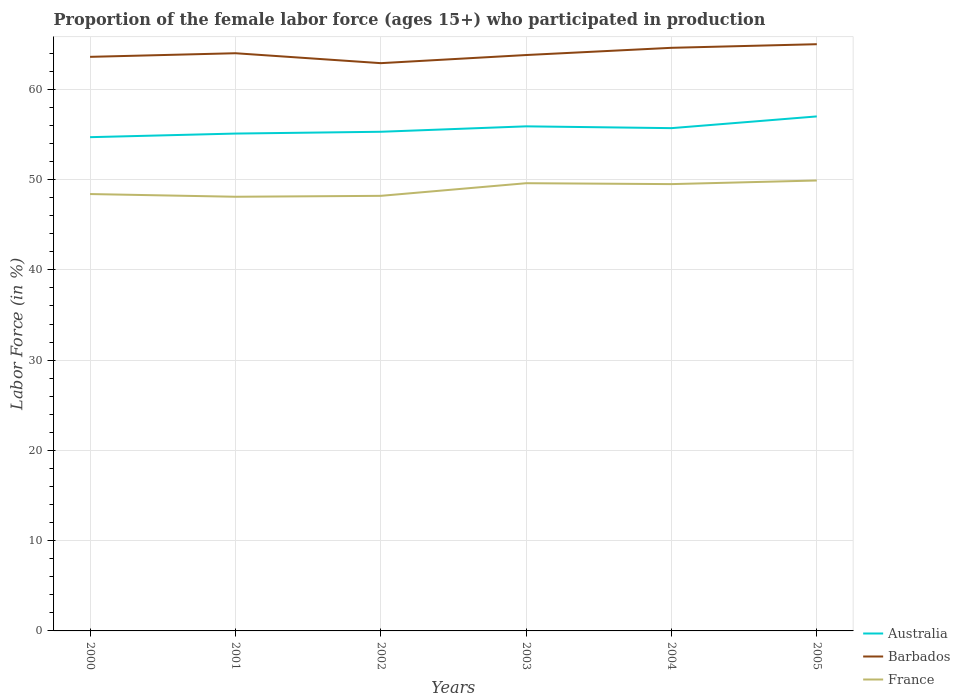How many different coloured lines are there?
Give a very brief answer. 3. Does the line corresponding to Barbados intersect with the line corresponding to France?
Provide a succinct answer. No. Is the number of lines equal to the number of legend labels?
Offer a terse response. Yes. Across all years, what is the maximum proportion of the female labor force who participated in production in France?
Offer a terse response. 48.1. What is the total proportion of the female labor force who participated in production in Australia in the graph?
Your response must be concise. -1.1. What is the difference between the highest and the second highest proportion of the female labor force who participated in production in France?
Offer a terse response. 1.8. What is the difference between the highest and the lowest proportion of the female labor force who participated in production in Barbados?
Offer a very short reply. 3. How many lines are there?
Give a very brief answer. 3. How many years are there in the graph?
Your answer should be very brief. 6. What is the difference between two consecutive major ticks on the Y-axis?
Your answer should be very brief. 10. Are the values on the major ticks of Y-axis written in scientific E-notation?
Offer a terse response. No. Does the graph contain grids?
Your answer should be very brief. Yes. How are the legend labels stacked?
Provide a short and direct response. Vertical. What is the title of the graph?
Give a very brief answer. Proportion of the female labor force (ages 15+) who participated in production. Does "Macedonia" appear as one of the legend labels in the graph?
Your answer should be compact. No. What is the label or title of the X-axis?
Provide a short and direct response. Years. What is the Labor Force (in %) in Australia in 2000?
Make the answer very short. 54.7. What is the Labor Force (in %) in Barbados in 2000?
Ensure brevity in your answer.  63.6. What is the Labor Force (in %) in France in 2000?
Give a very brief answer. 48.4. What is the Labor Force (in %) of Australia in 2001?
Provide a succinct answer. 55.1. What is the Labor Force (in %) of France in 2001?
Provide a short and direct response. 48.1. What is the Labor Force (in %) of Australia in 2002?
Keep it short and to the point. 55.3. What is the Labor Force (in %) of Barbados in 2002?
Your response must be concise. 62.9. What is the Labor Force (in %) in France in 2002?
Your response must be concise. 48.2. What is the Labor Force (in %) of Australia in 2003?
Give a very brief answer. 55.9. What is the Labor Force (in %) in Barbados in 2003?
Ensure brevity in your answer.  63.8. What is the Labor Force (in %) of France in 2003?
Ensure brevity in your answer.  49.6. What is the Labor Force (in %) of Australia in 2004?
Offer a very short reply. 55.7. What is the Labor Force (in %) of Barbados in 2004?
Provide a succinct answer. 64.6. What is the Labor Force (in %) of France in 2004?
Your response must be concise. 49.5. What is the Labor Force (in %) of Australia in 2005?
Your response must be concise. 57. What is the Labor Force (in %) in Barbados in 2005?
Your answer should be very brief. 65. What is the Labor Force (in %) of France in 2005?
Provide a succinct answer. 49.9. Across all years, what is the maximum Labor Force (in %) in France?
Offer a terse response. 49.9. Across all years, what is the minimum Labor Force (in %) of Australia?
Provide a succinct answer. 54.7. Across all years, what is the minimum Labor Force (in %) in Barbados?
Make the answer very short. 62.9. Across all years, what is the minimum Labor Force (in %) in France?
Make the answer very short. 48.1. What is the total Labor Force (in %) of Australia in the graph?
Make the answer very short. 333.7. What is the total Labor Force (in %) of Barbados in the graph?
Offer a terse response. 383.9. What is the total Labor Force (in %) in France in the graph?
Make the answer very short. 293.7. What is the difference between the Labor Force (in %) of France in 2000 and that in 2001?
Give a very brief answer. 0.3. What is the difference between the Labor Force (in %) of France in 2000 and that in 2002?
Your answer should be very brief. 0.2. What is the difference between the Labor Force (in %) of Australia in 2000 and that in 2003?
Your answer should be compact. -1.2. What is the difference between the Labor Force (in %) of Australia in 2000 and that in 2004?
Offer a very short reply. -1. What is the difference between the Labor Force (in %) of Barbados in 2000 and that in 2004?
Ensure brevity in your answer.  -1. What is the difference between the Labor Force (in %) of France in 2000 and that in 2004?
Your answer should be compact. -1.1. What is the difference between the Labor Force (in %) in Australia in 2000 and that in 2005?
Provide a succinct answer. -2.3. What is the difference between the Labor Force (in %) of France in 2001 and that in 2002?
Offer a terse response. -0.1. What is the difference between the Labor Force (in %) of Barbados in 2001 and that in 2003?
Give a very brief answer. 0.2. What is the difference between the Labor Force (in %) in France in 2001 and that in 2003?
Offer a terse response. -1.5. What is the difference between the Labor Force (in %) in Barbados in 2001 and that in 2004?
Your answer should be compact. -0.6. What is the difference between the Labor Force (in %) in France in 2001 and that in 2004?
Your answer should be very brief. -1.4. What is the difference between the Labor Force (in %) in Australia in 2001 and that in 2005?
Make the answer very short. -1.9. What is the difference between the Labor Force (in %) of Barbados in 2001 and that in 2005?
Offer a terse response. -1. What is the difference between the Labor Force (in %) in France in 2001 and that in 2005?
Your response must be concise. -1.8. What is the difference between the Labor Force (in %) in Barbados in 2002 and that in 2003?
Keep it short and to the point. -0.9. What is the difference between the Labor Force (in %) in Australia in 2002 and that in 2004?
Your answer should be very brief. -0.4. What is the difference between the Labor Force (in %) of Barbados in 2002 and that in 2004?
Give a very brief answer. -1.7. What is the difference between the Labor Force (in %) in France in 2002 and that in 2004?
Your answer should be very brief. -1.3. What is the difference between the Labor Force (in %) in Barbados in 2002 and that in 2005?
Offer a very short reply. -2.1. What is the difference between the Labor Force (in %) of Australia in 2003 and that in 2004?
Offer a very short reply. 0.2. What is the difference between the Labor Force (in %) of Barbados in 2003 and that in 2004?
Ensure brevity in your answer.  -0.8. What is the difference between the Labor Force (in %) in France in 2003 and that in 2004?
Give a very brief answer. 0.1. What is the difference between the Labor Force (in %) of France in 2003 and that in 2005?
Offer a very short reply. -0.3. What is the difference between the Labor Force (in %) of Barbados in 2004 and that in 2005?
Offer a terse response. -0.4. What is the difference between the Labor Force (in %) in Australia in 2000 and the Labor Force (in %) in Barbados in 2002?
Your answer should be compact. -8.2. What is the difference between the Labor Force (in %) of Barbados in 2000 and the Labor Force (in %) of France in 2002?
Your response must be concise. 15.4. What is the difference between the Labor Force (in %) in Australia in 2000 and the Labor Force (in %) in France in 2004?
Your response must be concise. 5.2. What is the difference between the Labor Force (in %) in Barbados in 2000 and the Labor Force (in %) in France in 2004?
Provide a succinct answer. 14.1. What is the difference between the Labor Force (in %) in Australia in 2000 and the Labor Force (in %) in Barbados in 2005?
Give a very brief answer. -10.3. What is the difference between the Labor Force (in %) of Australia in 2000 and the Labor Force (in %) of France in 2005?
Provide a succinct answer. 4.8. What is the difference between the Labor Force (in %) in Barbados in 2000 and the Labor Force (in %) in France in 2005?
Your answer should be compact. 13.7. What is the difference between the Labor Force (in %) in Australia in 2001 and the Labor Force (in %) in Barbados in 2002?
Provide a succinct answer. -7.8. What is the difference between the Labor Force (in %) in Australia in 2001 and the Labor Force (in %) in Barbados in 2003?
Keep it short and to the point. -8.7. What is the difference between the Labor Force (in %) of Australia in 2001 and the Labor Force (in %) of France in 2003?
Make the answer very short. 5.5. What is the difference between the Labor Force (in %) of Barbados in 2001 and the Labor Force (in %) of France in 2003?
Offer a very short reply. 14.4. What is the difference between the Labor Force (in %) of Australia in 2001 and the Labor Force (in %) of Barbados in 2004?
Make the answer very short. -9.5. What is the difference between the Labor Force (in %) of Australia in 2001 and the Labor Force (in %) of France in 2004?
Offer a terse response. 5.6. What is the difference between the Labor Force (in %) of Australia in 2001 and the Labor Force (in %) of Barbados in 2005?
Offer a terse response. -9.9. What is the difference between the Labor Force (in %) in Australia in 2001 and the Labor Force (in %) in France in 2005?
Your answer should be very brief. 5.2. What is the difference between the Labor Force (in %) of Barbados in 2002 and the Labor Force (in %) of France in 2003?
Give a very brief answer. 13.3. What is the difference between the Labor Force (in %) of Australia in 2002 and the Labor Force (in %) of France in 2004?
Your answer should be compact. 5.8. What is the difference between the Labor Force (in %) of Australia in 2002 and the Labor Force (in %) of Barbados in 2005?
Ensure brevity in your answer.  -9.7. What is the difference between the Labor Force (in %) of Barbados in 2002 and the Labor Force (in %) of France in 2005?
Ensure brevity in your answer.  13. What is the difference between the Labor Force (in %) of Australia in 2003 and the Labor Force (in %) of Barbados in 2005?
Provide a succinct answer. -9.1. What is the average Labor Force (in %) of Australia per year?
Offer a very short reply. 55.62. What is the average Labor Force (in %) in Barbados per year?
Give a very brief answer. 63.98. What is the average Labor Force (in %) in France per year?
Offer a terse response. 48.95. In the year 2000, what is the difference between the Labor Force (in %) in Australia and Labor Force (in %) in Barbados?
Offer a very short reply. -8.9. In the year 2001, what is the difference between the Labor Force (in %) in Australia and Labor Force (in %) in France?
Your answer should be compact. 7. In the year 2002, what is the difference between the Labor Force (in %) of Australia and Labor Force (in %) of Barbados?
Keep it short and to the point. -7.6. In the year 2002, what is the difference between the Labor Force (in %) in Barbados and Labor Force (in %) in France?
Your answer should be compact. 14.7. In the year 2003, what is the difference between the Labor Force (in %) in Australia and Labor Force (in %) in Barbados?
Your response must be concise. -7.9. In the year 2003, what is the difference between the Labor Force (in %) of Australia and Labor Force (in %) of France?
Keep it short and to the point. 6.3. In the year 2003, what is the difference between the Labor Force (in %) of Barbados and Labor Force (in %) of France?
Your answer should be very brief. 14.2. In the year 2004, what is the difference between the Labor Force (in %) in Australia and Labor Force (in %) in France?
Provide a succinct answer. 6.2. In the year 2005, what is the difference between the Labor Force (in %) in Australia and Labor Force (in %) in Barbados?
Ensure brevity in your answer.  -8. In the year 2005, what is the difference between the Labor Force (in %) of Australia and Labor Force (in %) of France?
Make the answer very short. 7.1. What is the ratio of the Labor Force (in %) in Australia in 2000 to that in 2001?
Make the answer very short. 0.99. What is the ratio of the Labor Force (in %) of Australia in 2000 to that in 2002?
Give a very brief answer. 0.99. What is the ratio of the Labor Force (in %) in Barbados in 2000 to that in 2002?
Provide a short and direct response. 1.01. What is the ratio of the Labor Force (in %) in France in 2000 to that in 2002?
Provide a succinct answer. 1. What is the ratio of the Labor Force (in %) of Australia in 2000 to that in 2003?
Ensure brevity in your answer.  0.98. What is the ratio of the Labor Force (in %) in Barbados in 2000 to that in 2003?
Provide a succinct answer. 1. What is the ratio of the Labor Force (in %) in France in 2000 to that in 2003?
Offer a very short reply. 0.98. What is the ratio of the Labor Force (in %) in Australia in 2000 to that in 2004?
Make the answer very short. 0.98. What is the ratio of the Labor Force (in %) of Barbados in 2000 to that in 2004?
Your response must be concise. 0.98. What is the ratio of the Labor Force (in %) in France in 2000 to that in 2004?
Provide a short and direct response. 0.98. What is the ratio of the Labor Force (in %) in Australia in 2000 to that in 2005?
Provide a short and direct response. 0.96. What is the ratio of the Labor Force (in %) of Barbados in 2000 to that in 2005?
Offer a terse response. 0.98. What is the ratio of the Labor Force (in %) of France in 2000 to that in 2005?
Your response must be concise. 0.97. What is the ratio of the Labor Force (in %) of Australia in 2001 to that in 2002?
Provide a succinct answer. 1. What is the ratio of the Labor Force (in %) in Barbados in 2001 to that in 2002?
Your answer should be very brief. 1.02. What is the ratio of the Labor Force (in %) in France in 2001 to that in 2002?
Your answer should be compact. 1. What is the ratio of the Labor Force (in %) of Australia in 2001 to that in 2003?
Offer a very short reply. 0.99. What is the ratio of the Labor Force (in %) in France in 2001 to that in 2003?
Offer a terse response. 0.97. What is the ratio of the Labor Force (in %) of Australia in 2001 to that in 2004?
Offer a very short reply. 0.99. What is the ratio of the Labor Force (in %) of France in 2001 to that in 2004?
Give a very brief answer. 0.97. What is the ratio of the Labor Force (in %) of Australia in 2001 to that in 2005?
Offer a terse response. 0.97. What is the ratio of the Labor Force (in %) of Barbados in 2001 to that in 2005?
Ensure brevity in your answer.  0.98. What is the ratio of the Labor Force (in %) in France in 2001 to that in 2005?
Your answer should be compact. 0.96. What is the ratio of the Labor Force (in %) of Australia in 2002 to that in 2003?
Make the answer very short. 0.99. What is the ratio of the Labor Force (in %) in Barbados in 2002 to that in 2003?
Your answer should be compact. 0.99. What is the ratio of the Labor Force (in %) of France in 2002 to that in 2003?
Provide a short and direct response. 0.97. What is the ratio of the Labor Force (in %) of Barbados in 2002 to that in 2004?
Give a very brief answer. 0.97. What is the ratio of the Labor Force (in %) of France in 2002 to that in 2004?
Offer a terse response. 0.97. What is the ratio of the Labor Force (in %) of Australia in 2002 to that in 2005?
Give a very brief answer. 0.97. What is the ratio of the Labor Force (in %) in France in 2002 to that in 2005?
Your response must be concise. 0.97. What is the ratio of the Labor Force (in %) of Barbados in 2003 to that in 2004?
Make the answer very short. 0.99. What is the ratio of the Labor Force (in %) in Australia in 2003 to that in 2005?
Offer a terse response. 0.98. What is the ratio of the Labor Force (in %) in Barbados in 2003 to that in 2005?
Your answer should be very brief. 0.98. What is the ratio of the Labor Force (in %) in Australia in 2004 to that in 2005?
Your answer should be very brief. 0.98. What is the ratio of the Labor Force (in %) of France in 2004 to that in 2005?
Provide a short and direct response. 0.99. What is the difference between the highest and the second highest Labor Force (in %) in Australia?
Your response must be concise. 1.1. What is the difference between the highest and the second highest Labor Force (in %) of Barbados?
Your answer should be compact. 0.4. What is the difference between the highest and the lowest Labor Force (in %) of Australia?
Your answer should be very brief. 2.3. 